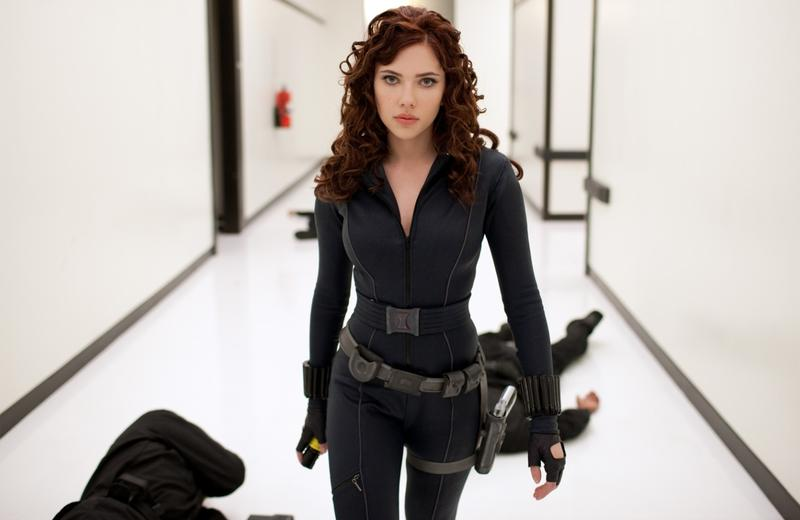Analyze the image in a comprehensive and detailed manner. The image depicts a dramatic and significant moment from a scene featuring a woman in a styled, combat-ready dark jumpsuit, which resembles typical attire in action or superhero films. She stands assertively in a minimalist white corridor adorned with black geometric lines, which emphasize the perspective and depth of the environment. Her expression is serious and contemplative, suggesting she might be strategizing or reflecting on recent events. Two apparent adversaries lie behind her, hinting at a recent skirmish. The setting and her costume help narrate a story of conflict, strength, and strategy - integral aspects of her character. 